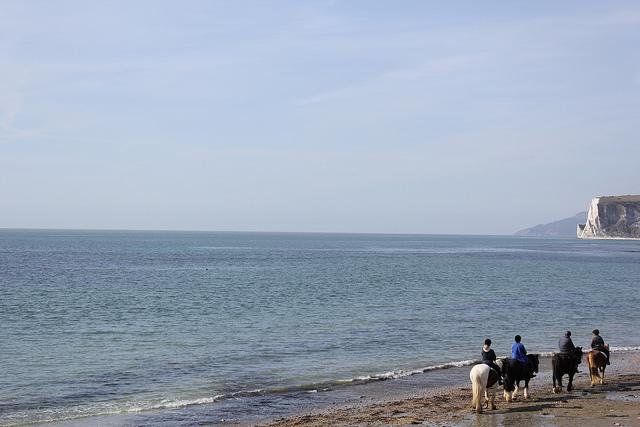What is the first terrain on the right? cliff 